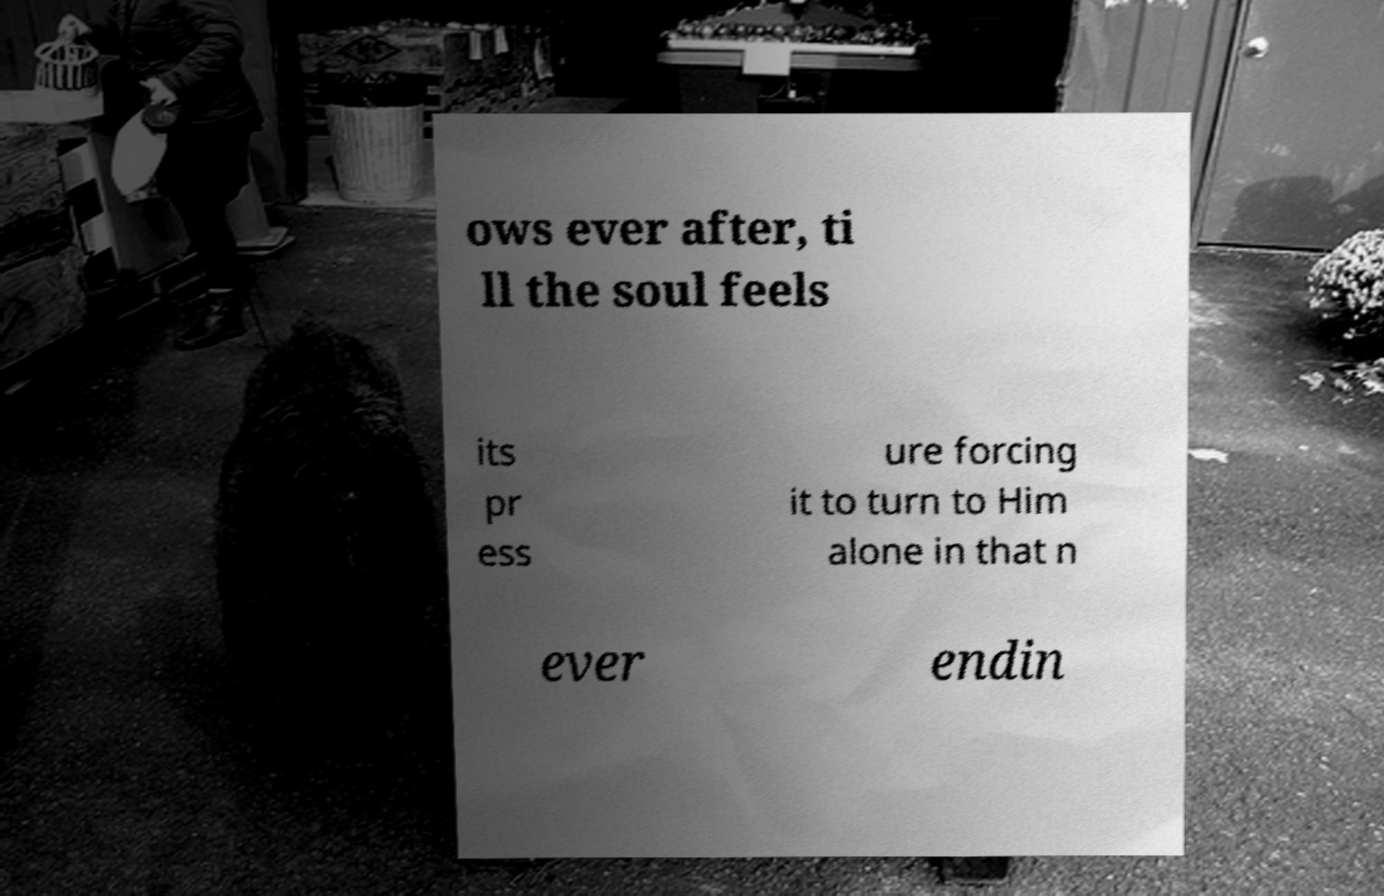Can you read and provide the text displayed in the image?This photo seems to have some interesting text. Can you extract and type it out for me? ows ever after, ti ll the soul feels its pr ess ure forcing it to turn to Him alone in that n ever endin 